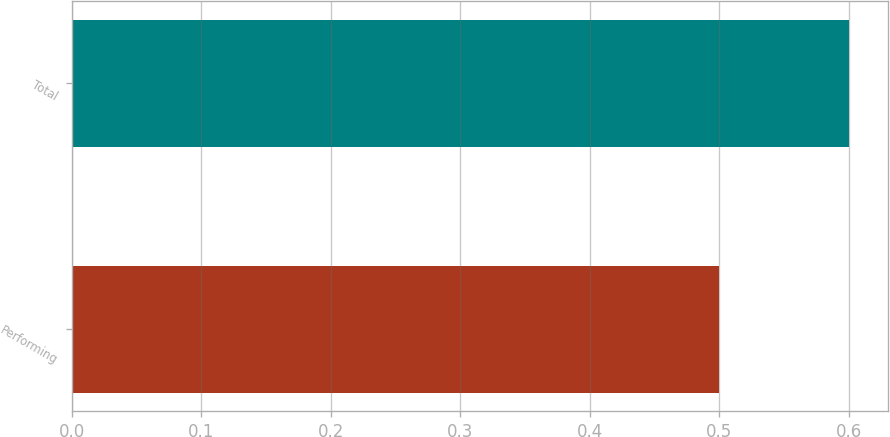<chart> <loc_0><loc_0><loc_500><loc_500><bar_chart><fcel>Performing<fcel>Total<nl><fcel>0.5<fcel>0.6<nl></chart> 